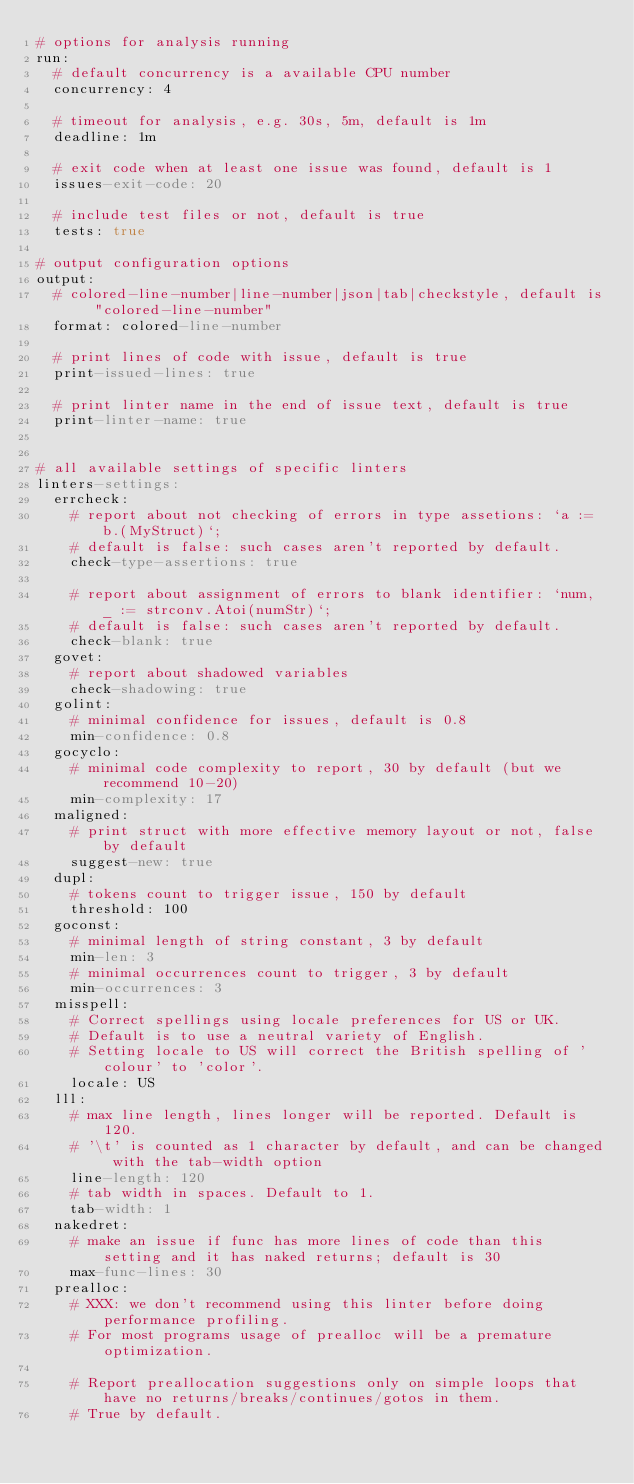Convert code to text. <code><loc_0><loc_0><loc_500><loc_500><_YAML_># options for analysis running
run:
  # default concurrency is a available CPU number
  concurrency: 4

  # timeout for analysis, e.g. 30s, 5m, default is 1m
  deadline: 1m

  # exit code when at least one issue was found, default is 1
  issues-exit-code: 20

  # include test files or not, default is true
  tests: true

# output configuration options
output:
  # colored-line-number|line-number|json|tab|checkstyle, default is "colored-line-number"
  format: colored-line-number

  # print lines of code with issue, default is true
  print-issued-lines: true

  # print linter name in the end of issue text, default is true
  print-linter-name: true


# all available settings of specific linters
linters-settings:
  errcheck:
    # report about not checking of errors in type assetions: `a := b.(MyStruct)`;
    # default is false: such cases aren't reported by default.
    check-type-assertions: true

    # report about assignment of errors to blank identifier: `num, _ := strconv.Atoi(numStr)`;
    # default is false: such cases aren't reported by default.
    check-blank: true
  govet:
    # report about shadowed variables
    check-shadowing: true
  golint:
    # minimal confidence for issues, default is 0.8
    min-confidence: 0.8
  gocyclo:
    # minimal code complexity to report, 30 by default (but we recommend 10-20)
    min-complexity: 17
  maligned:
    # print struct with more effective memory layout or not, false by default
    suggest-new: true
  dupl:
    # tokens count to trigger issue, 150 by default
    threshold: 100
  goconst:
    # minimal length of string constant, 3 by default
    min-len: 3
    # minimal occurrences count to trigger, 3 by default
    min-occurrences: 3
  misspell:
    # Correct spellings using locale preferences for US or UK.
    # Default is to use a neutral variety of English.
    # Setting locale to US will correct the British spelling of 'colour' to 'color'.
    locale: US
  lll:
    # max line length, lines longer will be reported. Default is 120.
    # '\t' is counted as 1 character by default, and can be changed with the tab-width option
    line-length: 120
    # tab width in spaces. Default to 1.
    tab-width: 1
  nakedret:
    # make an issue if func has more lines of code than this setting and it has naked returns; default is 30
    max-func-lines: 30
  prealloc:
    # XXX: we don't recommend using this linter before doing performance profiling.
    # For most programs usage of prealloc will be a premature optimization.

    # Report preallocation suggestions only on simple loops that have no returns/breaks/continues/gotos in them.
    # True by default.</code> 